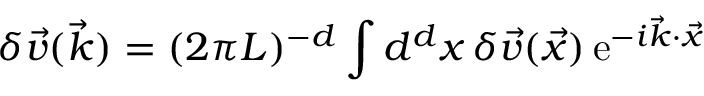Convert formula to latex. <formula><loc_0><loc_0><loc_500><loc_500>\delta \vec { v } ( \vec { k } ) = ( 2 \pi L ) ^ { - d } \int d ^ { d } { x } \, \delta \vec { v } ( \vec { x } ) \, e ^ { - i \vec { k } \cdot \vec { x } }</formula> 